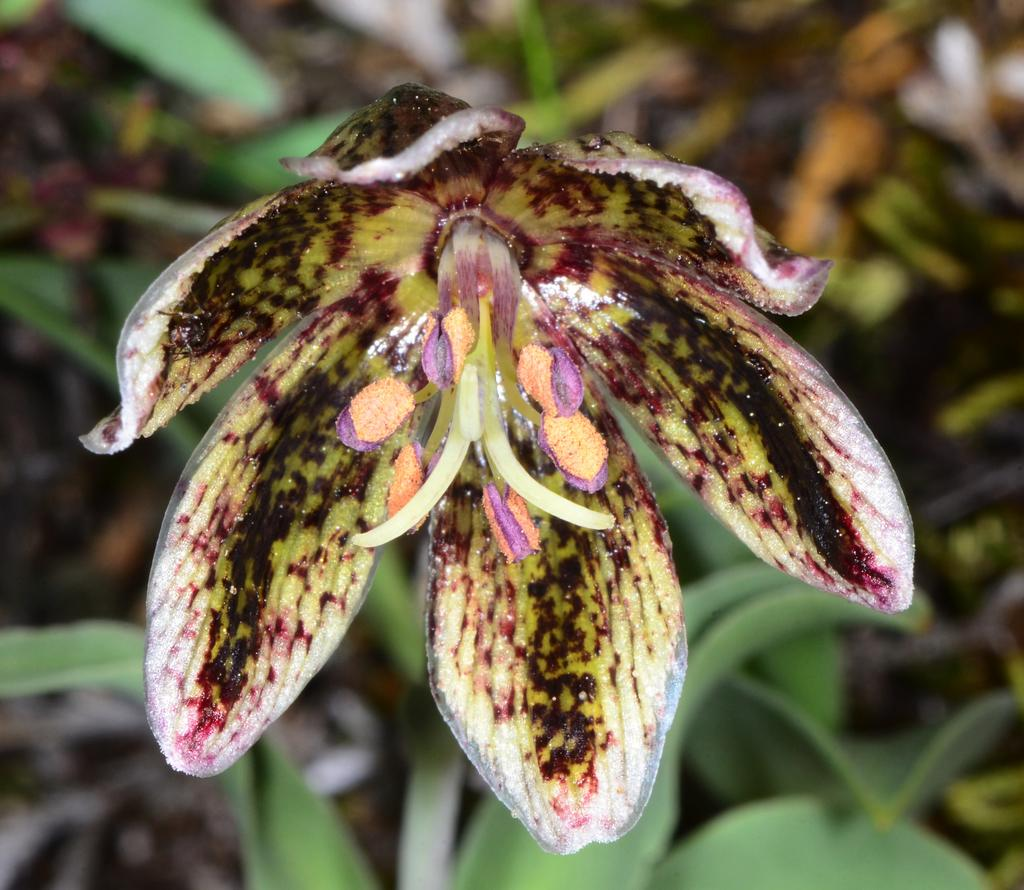What type of plant life can be seen in the image? There are flowers and leaves visible in the image. Can you describe the colors of the flowers in the image? The colors of the flowers in the image cannot be determined without more information. What is the context of the image, considering the presence of flowers and leaves? The image appears to be of a natural setting, such as a garden or park. Can you tell me how many people are walking through the flowers in the image? There are no people visible in the image; it only features flowers and leaves. 